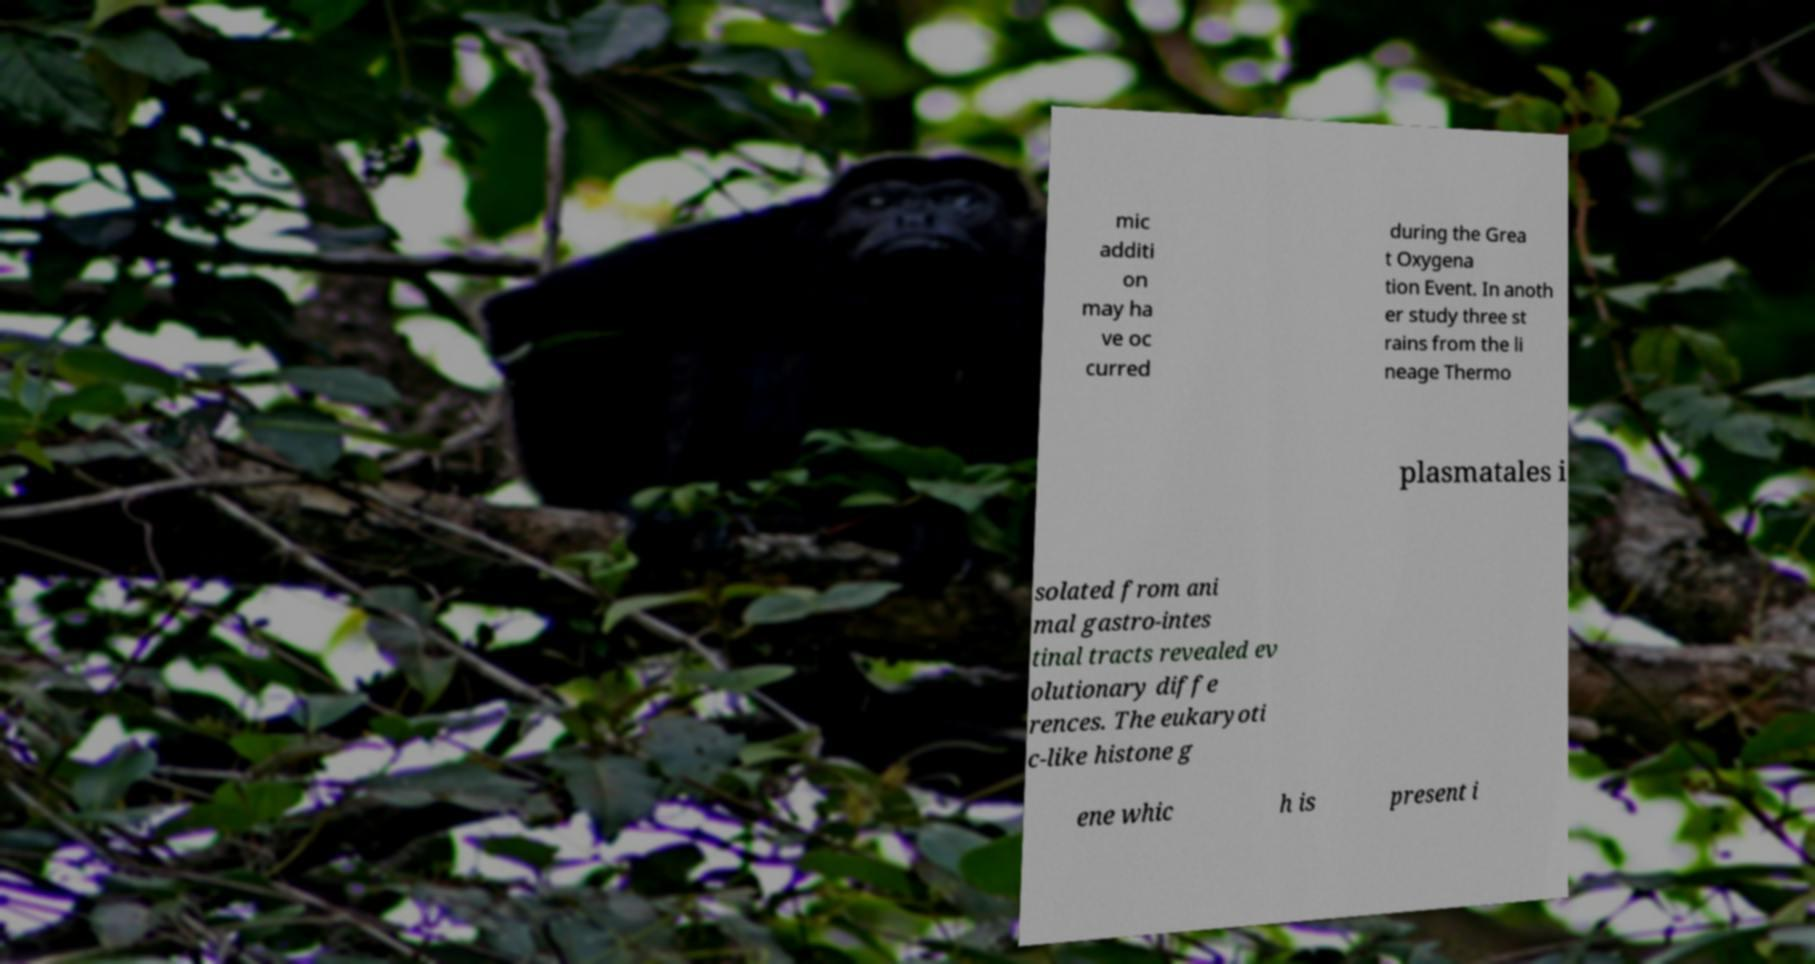Can you read and provide the text displayed in the image?This photo seems to have some interesting text. Can you extract and type it out for me? mic additi on may ha ve oc curred during the Grea t Oxygena tion Event. In anoth er study three st rains from the li neage Thermo plasmatales i solated from ani mal gastro-intes tinal tracts revealed ev olutionary diffe rences. The eukaryoti c-like histone g ene whic h is present i 